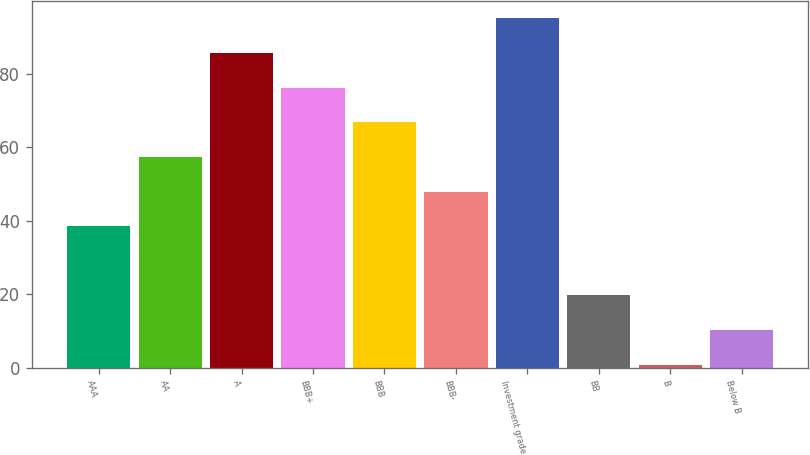Convert chart. <chart><loc_0><loc_0><loc_500><loc_500><bar_chart><fcel>AAA<fcel>AA<fcel>A<fcel>BBB+<fcel>BBB<fcel>BBB-<fcel>Investment grade<fcel>BB<fcel>B<fcel>Below B<nl><fcel>38.58<fcel>57.42<fcel>85.68<fcel>76.26<fcel>66.84<fcel>48<fcel>95.1<fcel>19.74<fcel>0.9<fcel>10.32<nl></chart> 